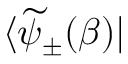Convert formula to latex. <formula><loc_0><loc_0><loc_500><loc_500>\langle \widetilde { \psi } _ { \pm } ( \beta ) |</formula> 